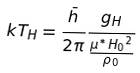<formula> <loc_0><loc_0><loc_500><loc_500>k T _ { H } = \frac { \bar { h } } { 2 { \pi } } \frac { g _ { H } } { \frac { { \mu } ^ { * } { H _ { 0 } } ^ { 2 } } { { \rho } _ { 0 } } }</formula> 